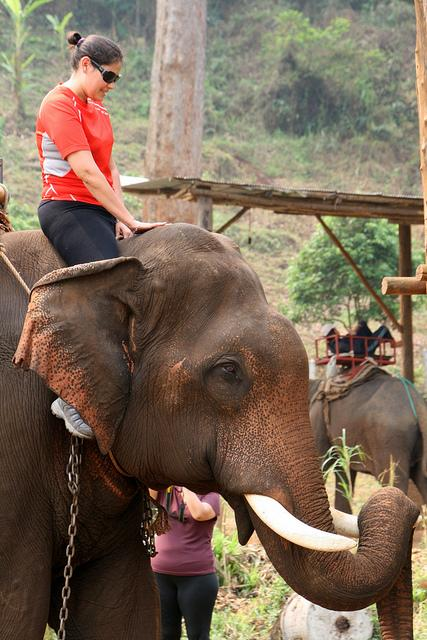Why is there a chain on the elephant? Please explain your reasoning. it's property. A person is riding an elephant. 